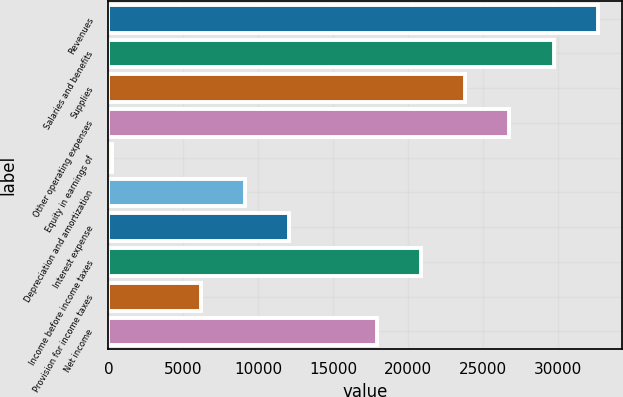<chart> <loc_0><loc_0><loc_500><loc_500><bar_chart><fcel>Revenues<fcel>Salaries and benefits<fcel>Supplies<fcel>Other operating expenses<fcel>Equity in earnings of<fcel>Depreciation and amortization<fcel>Interest expense<fcel>Income before income taxes<fcel>Provision for income taxes<fcel>Net income<nl><fcel>32624.4<fcel>29682<fcel>23797.2<fcel>26739.6<fcel>258<fcel>9085.2<fcel>12027.6<fcel>20854.8<fcel>6142.8<fcel>17912.4<nl></chart> 